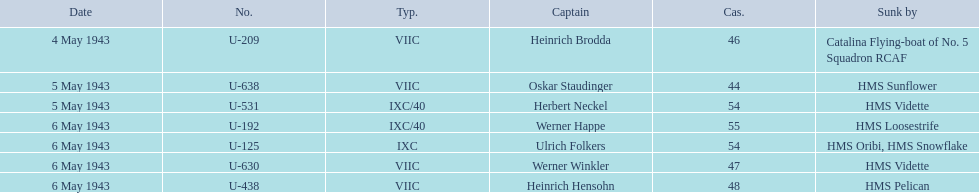Which sunken u-boat had the most casualties U-192. 